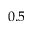Convert formula to latex. <formula><loc_0><loc_0><loc_500><loc_500>0 . 5</formula> 